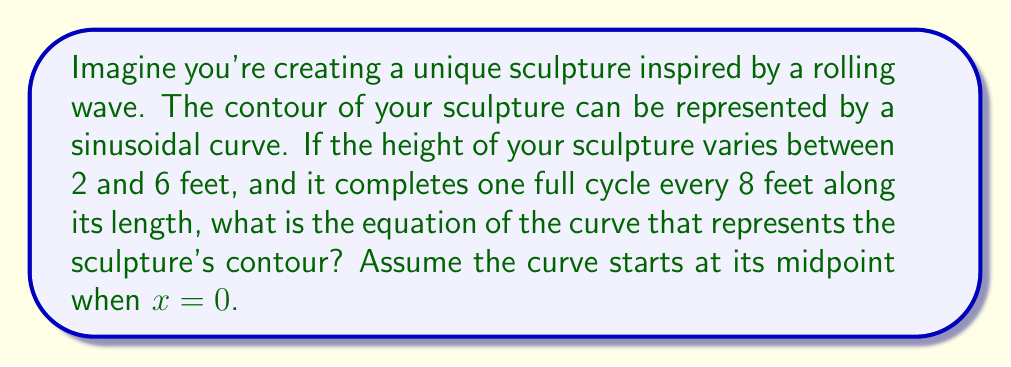Can you answer this question? Let's approach this step-by-step:

1) The general form of a sinusoidal function is:

   $$ y = A \sin(B(x - C)) + D $$

   where A is the amplitude, B is related to the period, C is the phase shift, and D is the vertical shift.

2) Let's find these parameters:

   - The height varies between 2 and 6 feet. The midline is at (6 + 2)/2 = 4 feet, so D = 4.
   - The amplitude is half the distance between the maximum and minimum: (6 - 2)/2 = 2 feet, so A = 2.
   - One full cycle is completed every 8 feet, so the period is 8. We know that $B = \frac{2\pi}{\text{period}}$, so $B = \frac{2\pi}{8} = \frac{\pi}{4}$.
   - The curve starts at its midpoint when x = 0, which means there's no phase shift, so C = 0.

3) Substituting these values into our general equation:

   $$ y = 2 \sin(\frac{\pi}{4}x) + 4 $$

4) This equation represents a sine curve that oscillates between 2 and 6, with a period of 8 feet, centered at y = 4.

[asy]
import graph;
size(200,100);
real f(real x) {return 2*sin(pi/4*x) + 4;}
draw(graph(f,-8,8),blue);
draw((-8,4)--(8,4),dashed);
label("y = 4 (midline)",(-8,4),W);
draw((-8,6)--(8,6),dotted);
draw((-8,2)--(8,2),dotted);
label("y = 6 (max)",(-8,6),W);
label("y = 2 (min)",(-8,2),W);
label("8 feet",(-4,0.5),S);
draw((-4,0)--(4,0),Arrows);
axes((-8,-1),(8,7),Arrow);
[/asy]
Answer: $$ y = 2 \sin(\frac{\pi}{4}x) + 4 $$ 